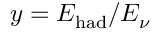<formula> <loc_0><loc_0><loc_500><loc_500>y = E _ { h a d } / E _ { \nu }</formula> 